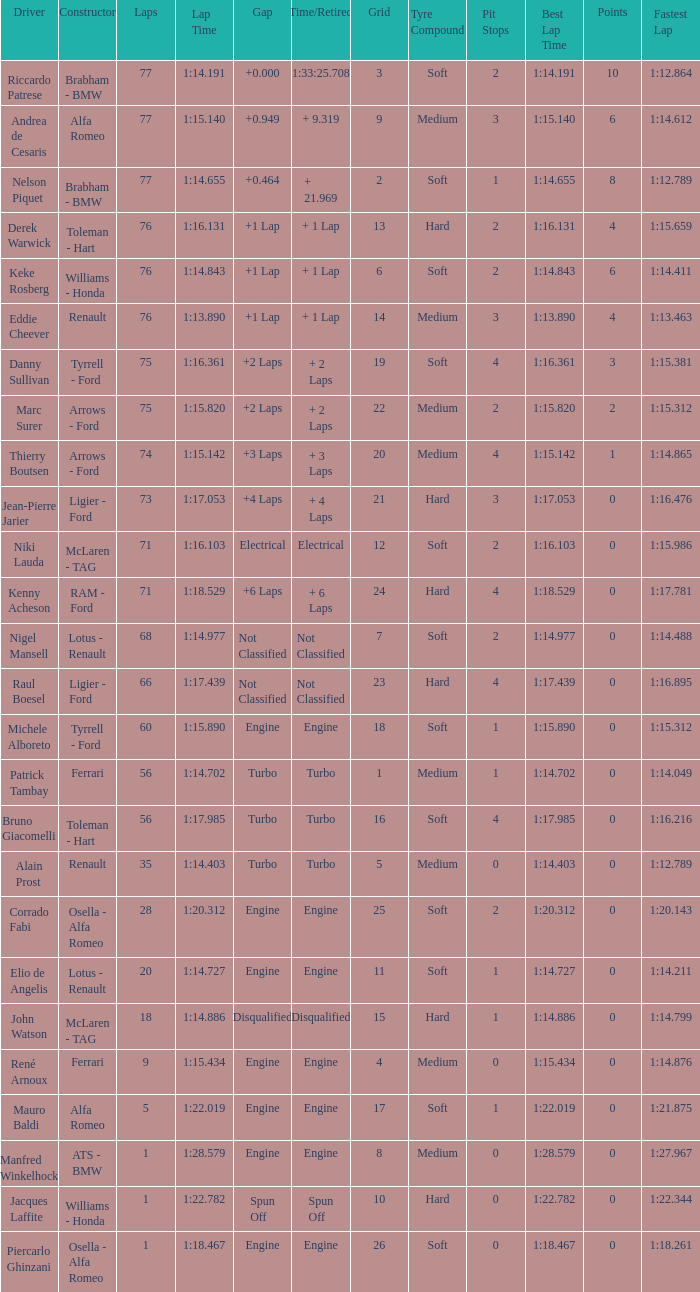Who drive the car that went under 60 laps and spun off? Jacques Laffite. 